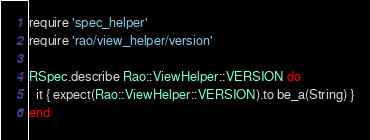Convert code to text. <code><loc_0><loc_0><loc_500><loc_500><_Ruby_>require 'spec_helper'
require 'rao/view_helper/version'

RSpec.describe Rao::ViewHelper::VERSION do
  it { expect(Rao::ViewHelper::VERSION).to be_a(String) }
end</code> 